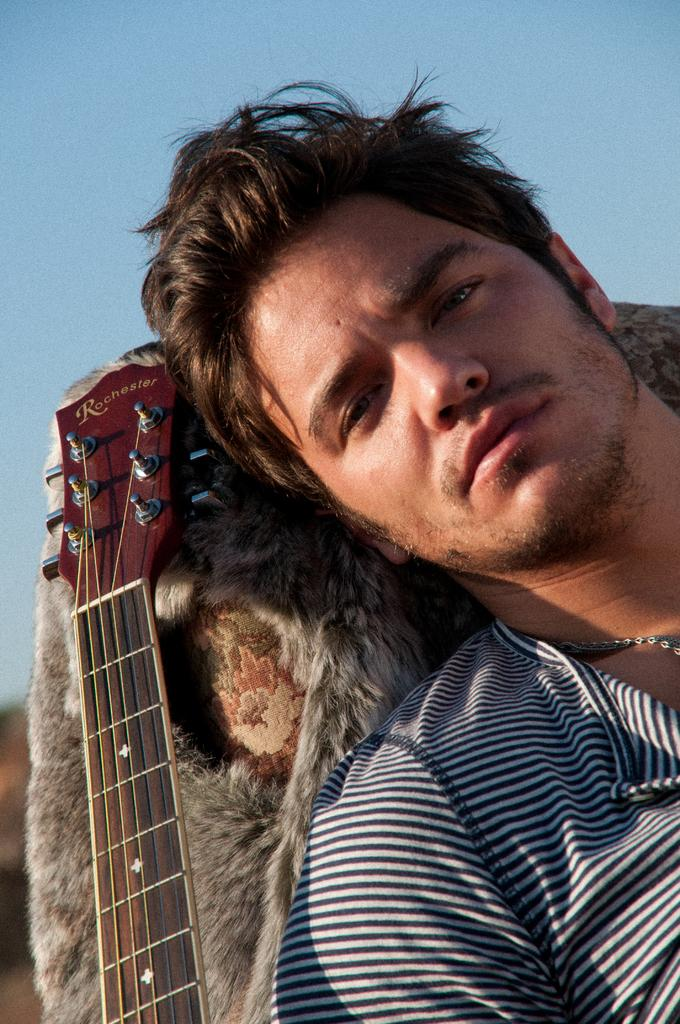What is the main subject of the picture? The main subject of the picture is a guy. What object is the guy sitting beside? The guy is sitting beside a guitar. What piece of furniture is the guy leaning on? The guy is leaning on a sofa. What type of cork can be seen in the image? There is no cork present in the image. What organization is the guy representing in the image? The image does not provide any information about the guy representing an organization. 